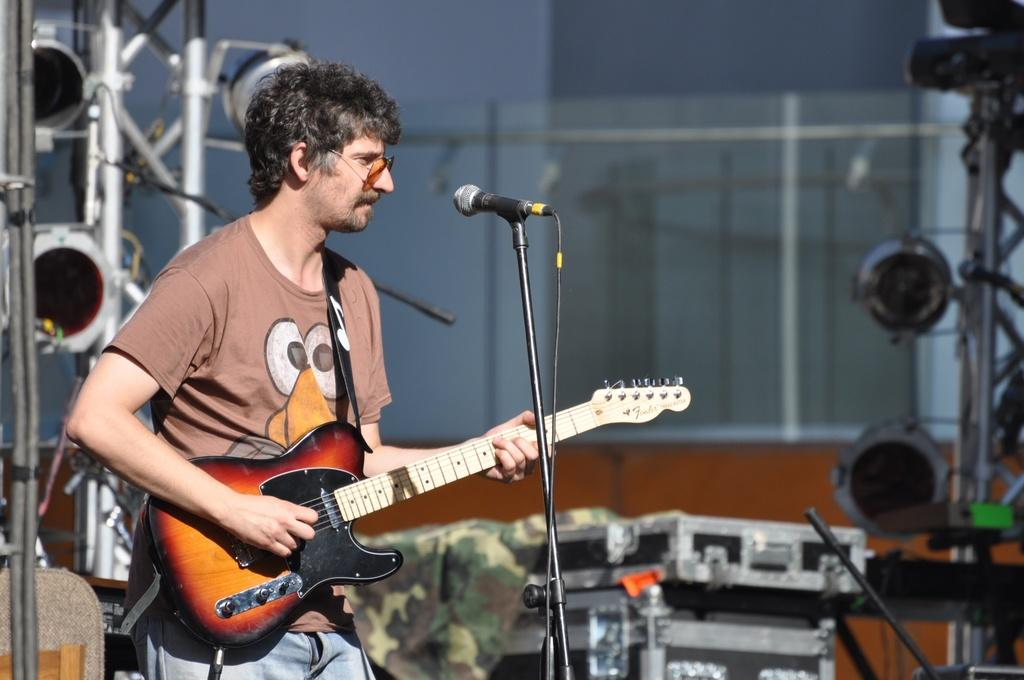Who is the main subject in the image? There is a person in the image. What is the person doing in the image? The person is standing in front of a microphone and playing the guitar. What other musical equipment can be seen in the image? There are music systems and sound boxes in the image. Where are the dolls placed in the image? There are no dolls present in the image. What type of linen is draped over the sound boxes in the image? There is no linen draped over the sound boxes in the image; they are visible as they are. 